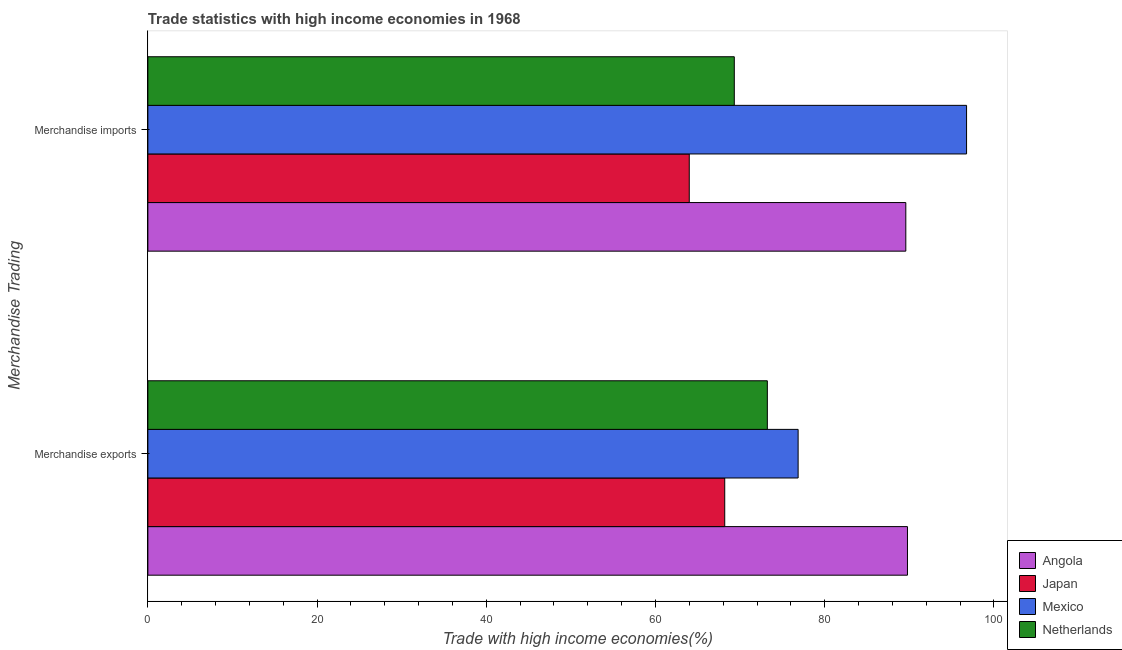How many different coloured bars are there?
Provide a short and direct response. 4. Are the number of bars per tick equal to the number of legend labels?
Your response must be concise. Yes. How many bars are there on the 2nd tick from the top?
Your answer should be very brief. 4. How many bars are there on the 1st tick from the bottom?
Give a very brief answer. 4. What is the label of the 1st group of bars from the top?
Your answer should be compact. Merchandise imports. What is the merchandise imports in Angola?
Your answer should be very brief. 89.58. Across all countries, what is the maximum merchandise imports?
Offer a terse response. 96.76. Across all countries, what is the minimum merchandise exports?
Provide a succinct answer. 68.18. In which country was the merchandise imports maximum?
Provide a succinct answer. Mexico. What is the total merchandise imports in the graph?
Ensure brevity in your answer.  319.65. What is the difference between the merchandise exports in Netherlands and that in Mexico?
Offer a very short reply. -3.64. What is the difference between the merchandise imports in Japan and the merchandise exports in Netherlands?
Ensure brevity in your answer.  -9.23. What is the average merchandise imports per country?
Offer a very short reply. 79.91. What is the difference between the merchandise imports and merchandise exports in Angola?
Provide a short and direct response. -0.2. What is the ratio of the merchandise imports in Mexico to that in Netherlands?
Ensure brevity in your answer.  1.4. In how many countries, is the merchandise imports greater than the average merchandise imports taken over all countries?
Provide a succinct answer. 2. What does the 4th bar from the top in Merchandise imports represents?
Give a very brief answer. Angola. What does the 2nd bar from the bottom in Merchandise imports represents?
Offer a very short reply. Japan. How many bars are there?
Your answer should be very brief. 8. What is the difference between two consecutive major ticks on the X-axis?
Your answer should be very brief. 20. Does the graph contain grids?
Your answer should be compact. No. How are the legend labels stacked?
Offer a terse response. Vertical. What is the title of the graph?
Offer a very short reply. Trade statistics with high income economies in 1968. Does "Chile" appear as one of the legend labels in the graph?
Ensure brevity in your answer.  No. What is the label or title of the X-axis?
Your response must be concise. Trade with high income economies(%). What is the label or title of the Y-axis?
Your answer should be very brief. Merchandise Trading. What is the Trade with high income economies(%) of Angola in Merchandise exports?
Your answer should be very brief. 89.78. What is the Trade with high income economies(%) of Japan in Merchandise exports?
Provide a short and direct response. 68.18. What is the Trade with high income economies(%) in Mexico in Merchandise exports?
Provide a short and direct response. 76.86. What is the Trade with high income economies(%) of Netherlands in Merchandise exports?
Make the answer very short. 73.22. What is the Trade with high income economies(%) of Angola in Merchandise imports?
Your response must be concise. 89.58. What is the Trade with high income economies(%) of Japan in Merchandise imports?
Offer a terse response. 63.99. What is the Trade with high income economies(%) in Mexico in Merchandise imports?
Offer a very short reply. 96.76. What is the Trade with high income economies(%) in Netherlands in Merchandise imports?
Make the answer very short. 69.31. Across all Merchandise Trading, what is the maximum Trade with high income economies(%) of Angola?
Your response must be concise. 89.78. Across all Merchandise Trading, what is the maximum Trade with high income economies(%) in Japan?
Offer a terse response. 68.18. Across all Merchandise Trading, what is the maximum Trade with high income economies(%) in Mexico?
Ensure brevity in your answer.  96.76. Across all Merchandise Trading, what is the maximum Trade with high income economies(%) of Netherlands?
Make the answer very short. 73.22. Across all Merchandise Trading, what is the minimum Trade with high income economies(%) in Angola?
Keep it short and to the point. 89.58. Across all Merchandise Trading, what is the minimum Trade with high income economies(%) in Japan?
Your response must be concise. 63.99. Across all Merchandise Trading, what is the minimum Trade with high income economies(%) in Mexico?
Your answer should be compact. 76.86. Across all Merchandise Trading, what is the minimum Trade with high income economies(%) in Netherlands?
Your answer should be very brief. 69.31. What is the total Trade with high income economies(%) in Angola in the graph?
Give a very brief answer. 179.36. What is the total Trade with high income economies(%) of Japan in the graph?
Your response must be concise. 132.17. What is the total Trade with high income economies(%) in Mexico in the graph?
Your answer should be compact. 173.62. What is the total Trade with high income economies(%) of Netherlands in the graph?
Your response must be concise. 142.53. What is the difference between the Trade with high income economies(%) of Angola in Merchandise exports and that in Merchandise imports?
Keep it short and to the point. 0.2. What is the difference between the Trade with high income economies(%) of Japan in Merchandise exports and that in Merchandise imports?
Give a very brief answer. 4.19. What is the difference between the Trade with high income economies(%) in Mexico in Merchandise exports and that in Merchandise imports?
Make the answer very short. -19.91. What is the difference between the Trade with high income economies(%) of Netherlands in Merchandise exports and that in Merchandise imports?
Offer a very short reply. 3.9. What is the difference between the Trade with high income economies(%) of Angola in Merchandise exports and the Trade with high income economies(%) of Japan in Merchandise imports?
Give a very brief answer. 25.79. What is the difference between the Trade with high income economies(%) of Angola in Merchandise exports and the Trade with high income economies(%) of Mexico in Merchandise imports?
Offer a terse response. -6.98. What is the difference between the Trade with high income economies(%) of Angola in Merchandise exports and the Trade with high income economies(%) of Netherlands in Merchandise imports?
Offer a terse response. 20.47. What is the difference between the Trade with high income economies(%) of Japan in Merchandise exports and the Trade with high income economies(%) of Mexico in Merchandise imports?
Your answer should be compact. -28.58. What is the difference between the Trade with high income economies(%) of Japan in Merchandise exports and the Trade with high income economies(%) of Netherlands in Merchandise imports?
Give a very brief answer. -1.13. What is the difference between the Trade with high income economies(%) of Mexico in Merchandise exports and the Trade with high income economies(%) of Netherlands in Merchandise imports?
Your answer should be very brief. 7.54. What is the average Trade with high income economies(%) of Angola per Merchandise Trading?
Your response must be concise. 89.68. What is the average Trade with high income economies(%) of Japan per Merchandise Trading?
Provide a succinct answer. 66.08. What is the average Trade with high income economies(%) in Mexico per Merchandise Trading?
Your answer should be very brief. 86.81. What is the average Trade with high income economies(%) in Netherlands per Merchandise Trading?
Make the answer very short. 71.26. What is the difference between the Trade with high income economies(%) of Angola and Trade with high income economies(%) of Japan in Merchandise exports?
Your answer should be very brief. 21.6. What is the difference between the Trade with high income economies(%) in Angola and Trade with high income economies(%) in Mexico in Merchandise exports?
Your answer should be compact. 12.92. What is the difference between the Trade with high income economies(%) in Angola and Trade with high income economies(%) in Netherlands in Merchandise exports?
Offer a terse response. 16.56. What is the difference between the Trade with high income economies(%) of Japan and Trade with high income economies(%) of Mexico in Merchandise exports?
Provide a succinct answer. -8.67. What is the difference between the Trade with high income economies(%) of Japan and Trade with high income economies(%) of Netherlands in Merchandise exports?
Your answer should be compact. -5.04. What is the difference between the Trade with high income economies(%) of Mexico and Trade with high income economies(%) of Netherlands in Merchandise exports?
Keep it short and to the point. 3.64. What is the difference between the Trade with high income economies(%) of Angola and Trade with high income economies(%) of Japan in Merchandise imports?
Offer a terse response. 25.6. What is the difference between the Trade with high income economies(%) in Angola and Trade with high income economies(%) in Mexico in Merchandise imports?
Provide a short and direct response. -7.18. What is the difference between the Trade with high income economies(%) of Angola and Trade with high income economies(%) of Netherlands in Merchandise imports?
Offer a terse response. 20.27. What is the difference between the Trade with high income economies(%) of Japan and Trade with high income economies(%) of Mexico in Merchandise imports?
Ensure brevity in your answer.  -32.77. What is the difference between the Trade with high income economies(%) of Japan and Trade with high income economies(%) of Netherlands in Merchandise imports?
Offer a very short reply. -5.32. What is the difference between the Trade with high income economies(%) in Mexico and Trade with high income economies(%) in Netherlands in Merchandise imports?
Offer a terse response. 27.45. What is the ratio of the Trade with high income economies(%) of Angola in Merchandise exports to that in Merchandise imports?
Provide a short and direct response. 1. What is the ratio of the Trade with high income economies(%) of Japan in Merchandise exports to that in Merchandise imports?
Your response must be concise. 1.07. What is the ratio of the Trade with high income economies(%) in Mexico in Merchandise exports to that in Merchandise imports?
Ensure brevity in your answer.  0.79. What is the ratio of the Trade with high income economies(%) of Netherlands in Merchandise exports to that in Merchandise imports?
Offer a very short reply. 1.06. What is the difference between the highest and the second highest Trade with high income economies(%) in Angola?
Your response must be concise. 0.2. What is the difference between the highest and the second highest Trade with high income economies(%) of Japan?
Give a very brief answer. 4.19. What is the difference between the highest and the second highest Trade with high income economies(%) in Mexico?
Offer a very short reply. 19.91. What is the difference between the highest and the second highest Trade with high income economies(%) of Netherlands?
Keep it short and to the point. 3.9. What is the difference between the highest and the lowest Trade with high income economies(%) of Angola?
Make the answer very short. 0.2. What is the difference between the highest and the lowest Trade with high income economies(%) of Japan?
Make the answer very short. 4.19. What is the difference between the highest and the lowest Trade with high income economies(%) in Mexico?
Your response must be concise. 19.91. What is the difference between the highest and the lowest Trade with high income economies(%) of Netherlands?
Provide a short and direct response. 3.9. 